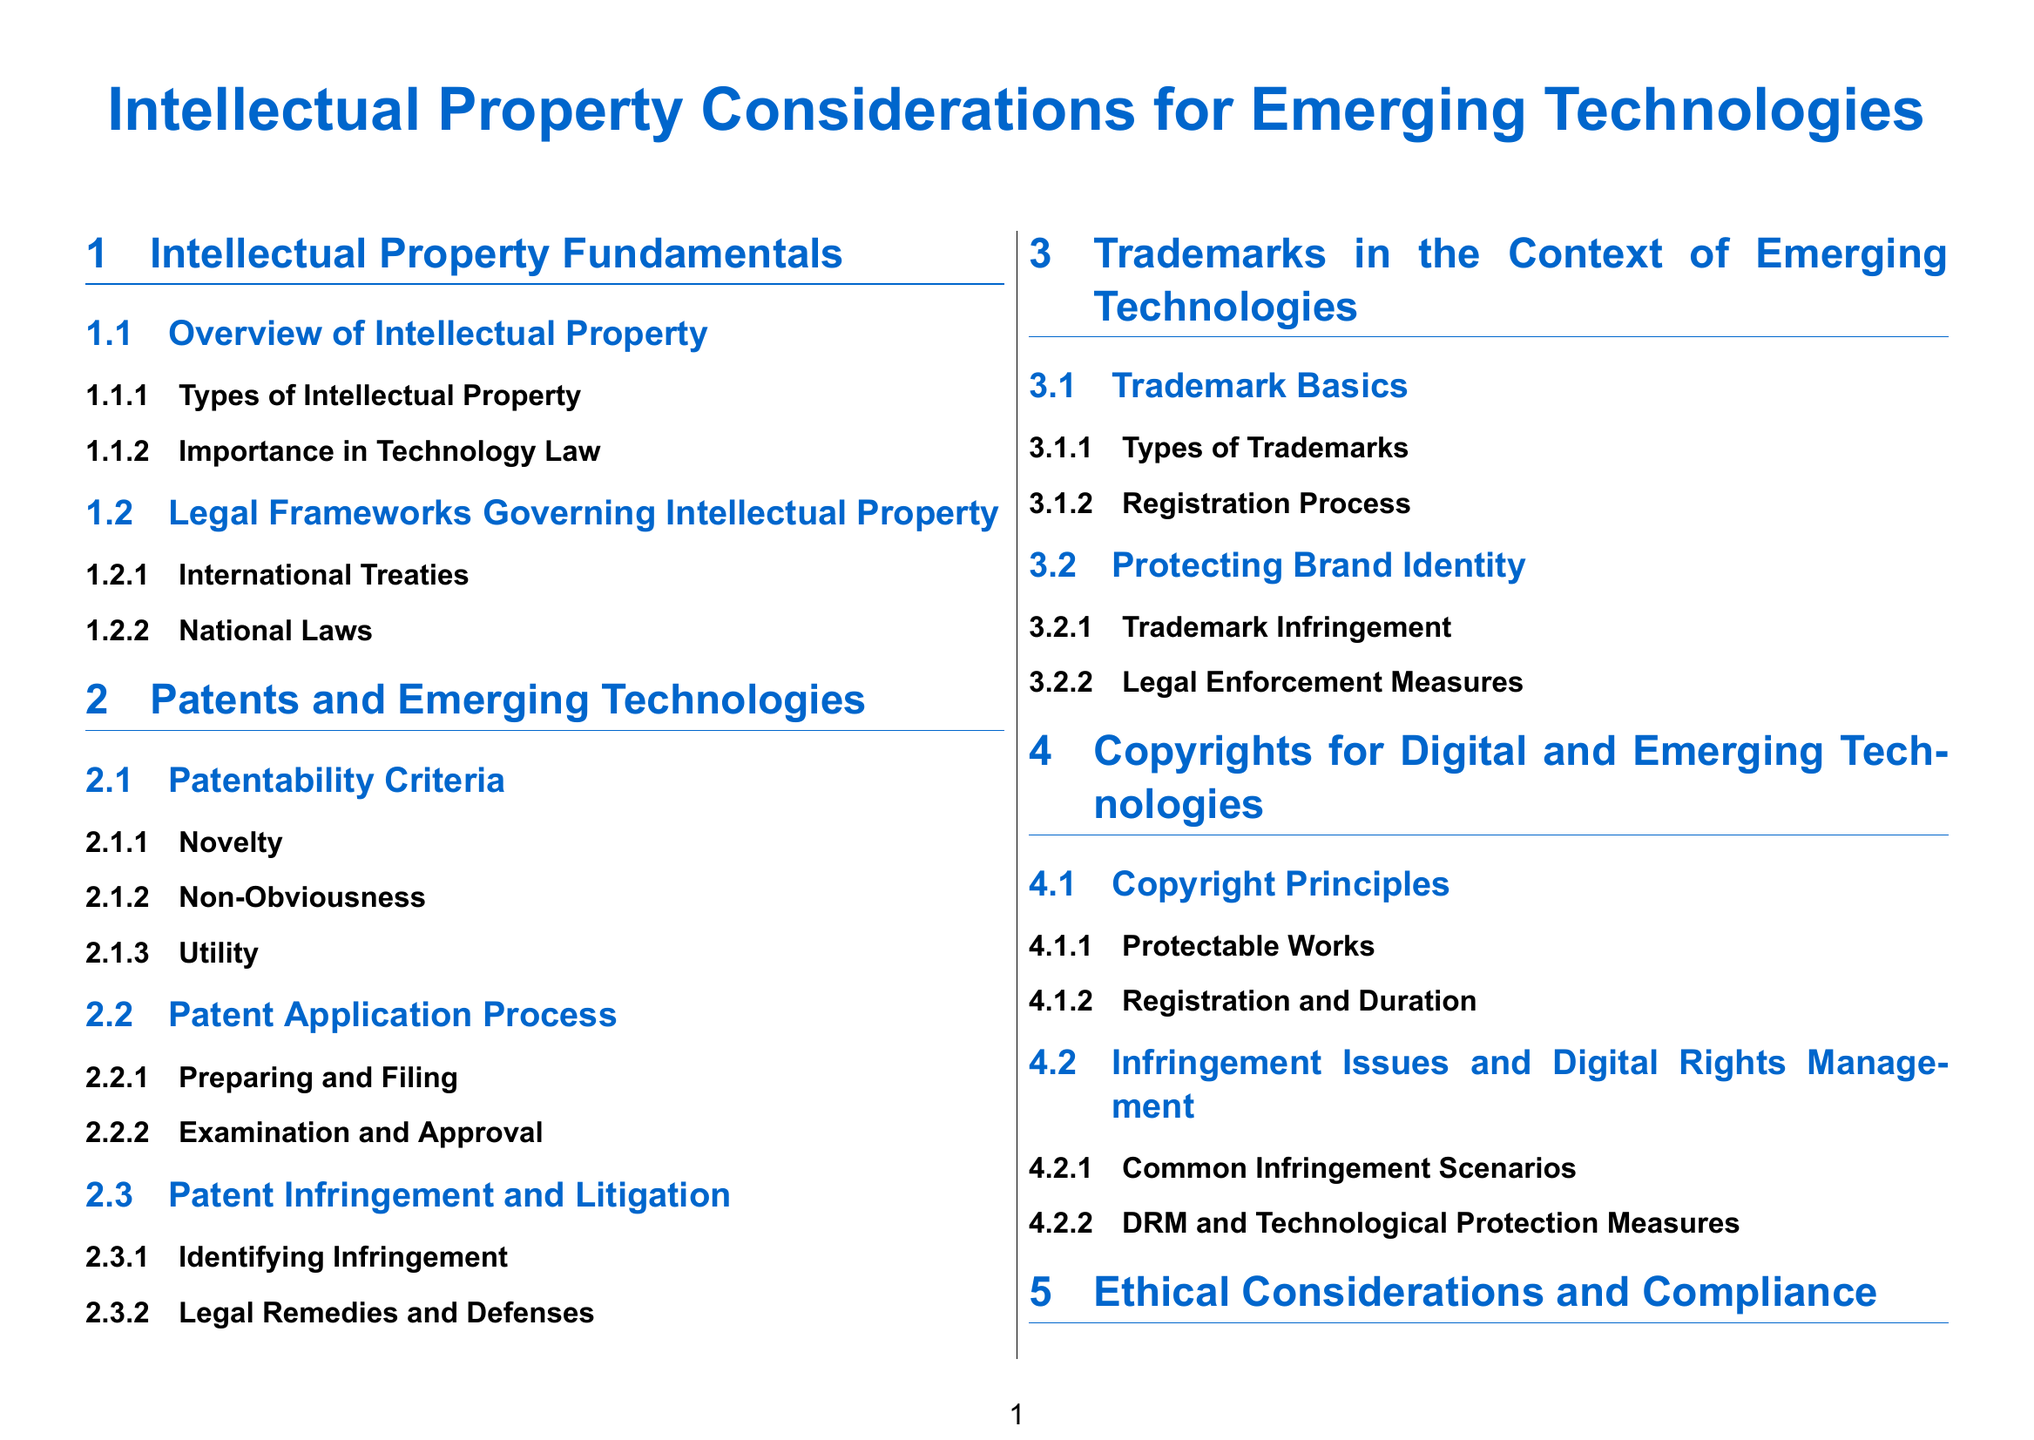What are the types of intellectual property? The document lists "Types of Intellectual Property" as a subsubsection under "Overview of Intellectual Property."
Answer: Types of Intellectual Property What are the patentability criteria? "Patentability Criteria" is a subheading under "Patents and Emerging Technologies," which implies it covers the main aspects of patents.
Answer: Patentability Criteria What is one of the common infringement scenarios? Under "Copyright Infringement Issues and Digital Rights Management," it mentions "Common Infringement Scenarios."
Answer: Common Infringement Scenarios What section discusses ethical implications? The section "Ethical Implications in IP Management" is found under "Ethical Considerations and Compliance."
Answer: Ethical Implications in IP Management What is the focus of the section regarding trademarks? The section is titled "Trademarks in the Context of Emerging Technologies," indicating its primary focus.
Answer: Trademarks in the Context of Emerging Technologies 